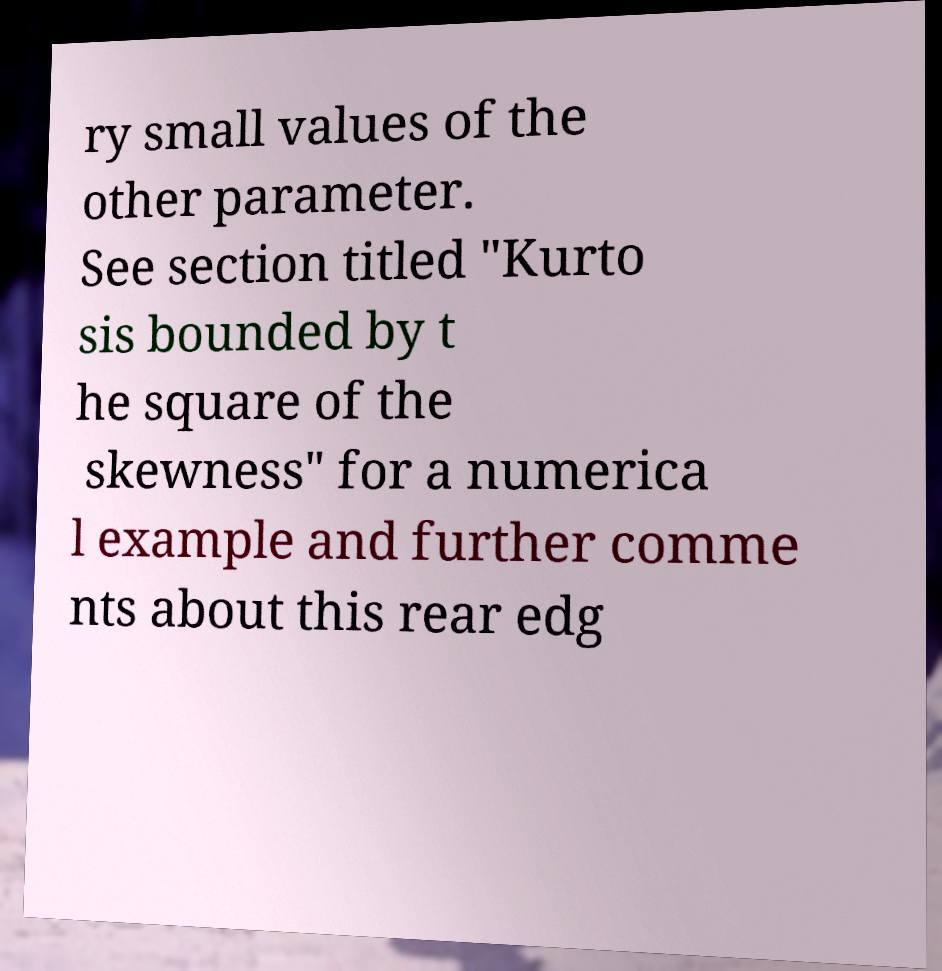Please identify and transcribe the text found in this image. ry small values of the other parameter. See section titled "Kurto sis bounded by t he square of the skewness" for a numerica l example and further comme nts about this rear edg 